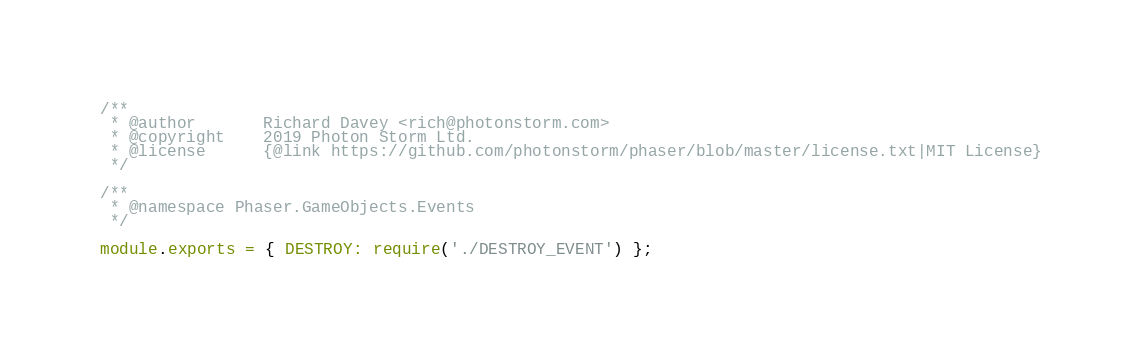Convert code to text. <code><loc_0><loc_0><loc_500><loc_500><_JavaScript_>/**
 * @author       Richard Davey <rich@photonstorm.com>
 * @copyright    2019 Photon Storm Ltd.
 * @license      {@link https://github.com/photonstorm/phaser/blob/master/license.txt|MIT License}
 */

/**
 * @namespace Phaser.GameObjects.Events
 */

module.exports = { DESTROY: require('./DESTROY_EVENT') };
</code> 